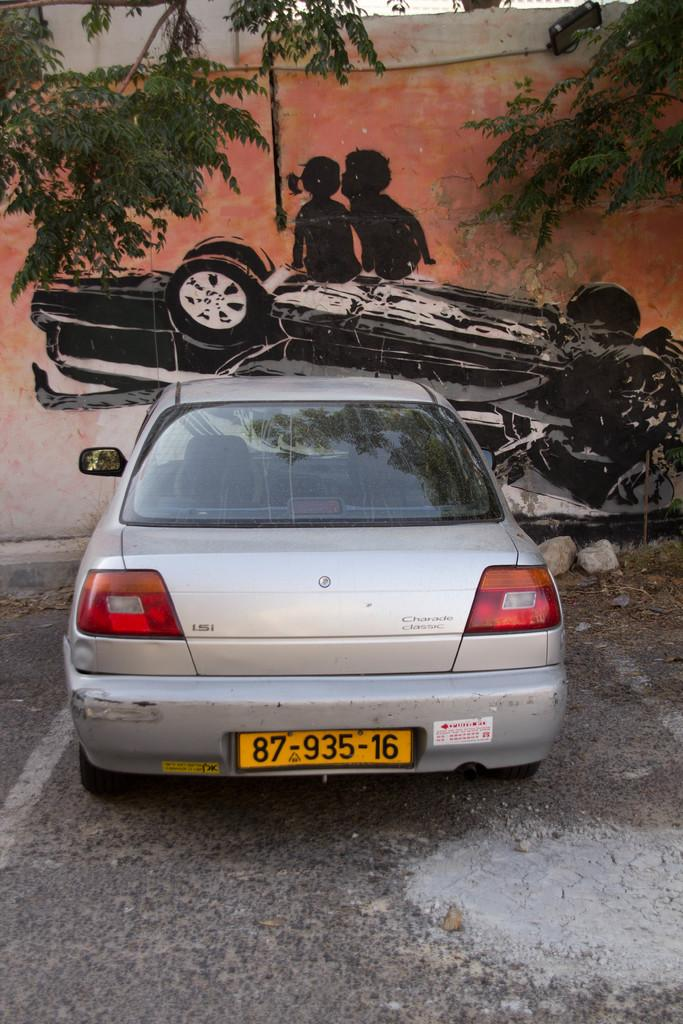<image>
Relay a brief, clear account of the picture shown. A parked grey Charade Classic car with a scratch on the left side. 